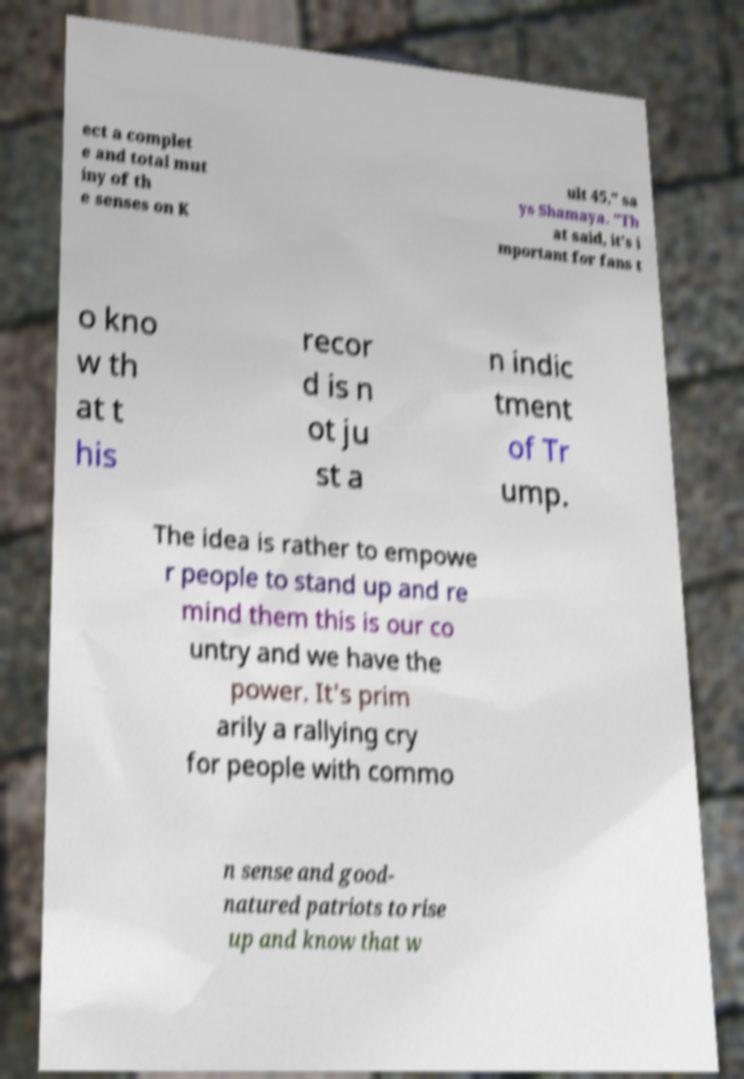There's text embedded in this image that I need extracted. Can you transcribe it verbatim? ect a complet e and total mut iny of th e senses on K ult 45," sa ys Shamaya. "Th at said, it's i mportant for fans t o kno w th at t his recor d is n ot ju st a n indic tment of Tr ump. The idea is rather to empowe r people to stand up and re mind them this is our co untry and we have the power. It's prim arily a rallying cry for people with commo n sense and good- natured patriots to rise up and know that w 